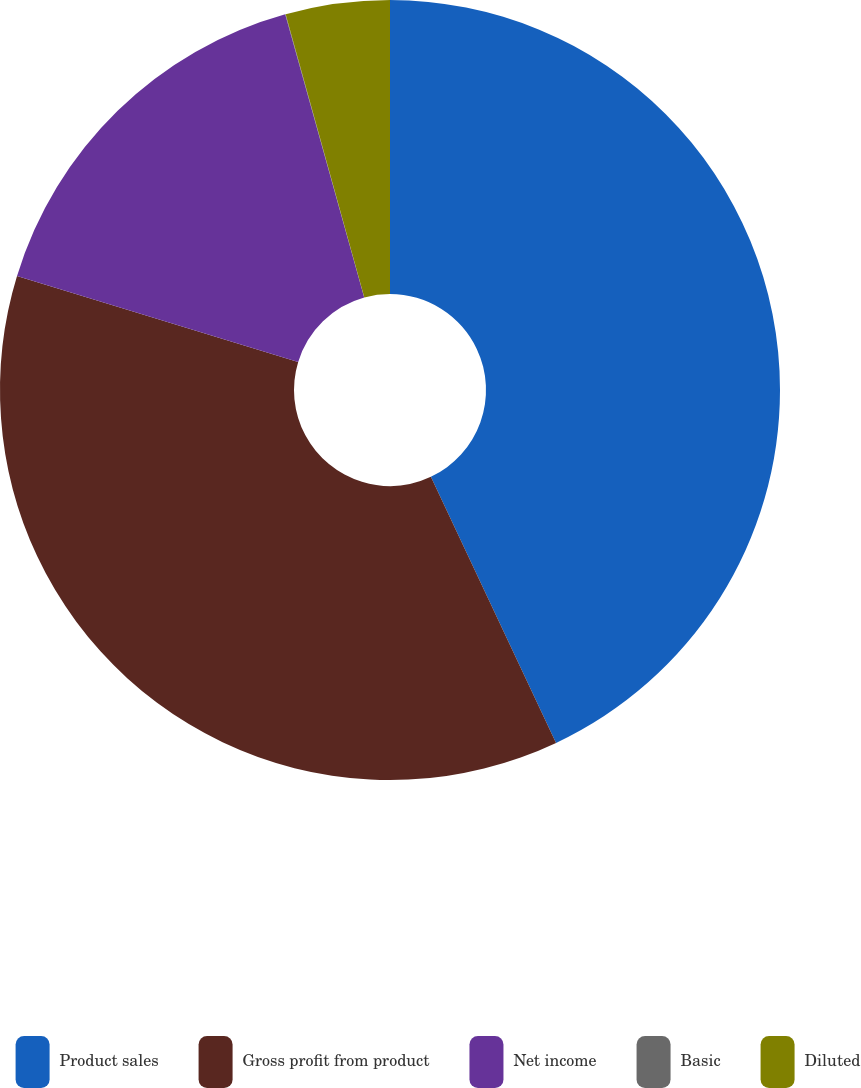Convert chart to OTSL. <chart><loc_0><loc_0><loc_500><loc_500><pie_chart><fcel>Product sales<fcel>Gross profit from product<fcel>Net income<fcel>Basic<fcel>Diluted<nl><fcel>43.0%<fcel>36.72%<fcel>15.95%<fcel>0.02%<fcel>4.31%<nl></chart> 